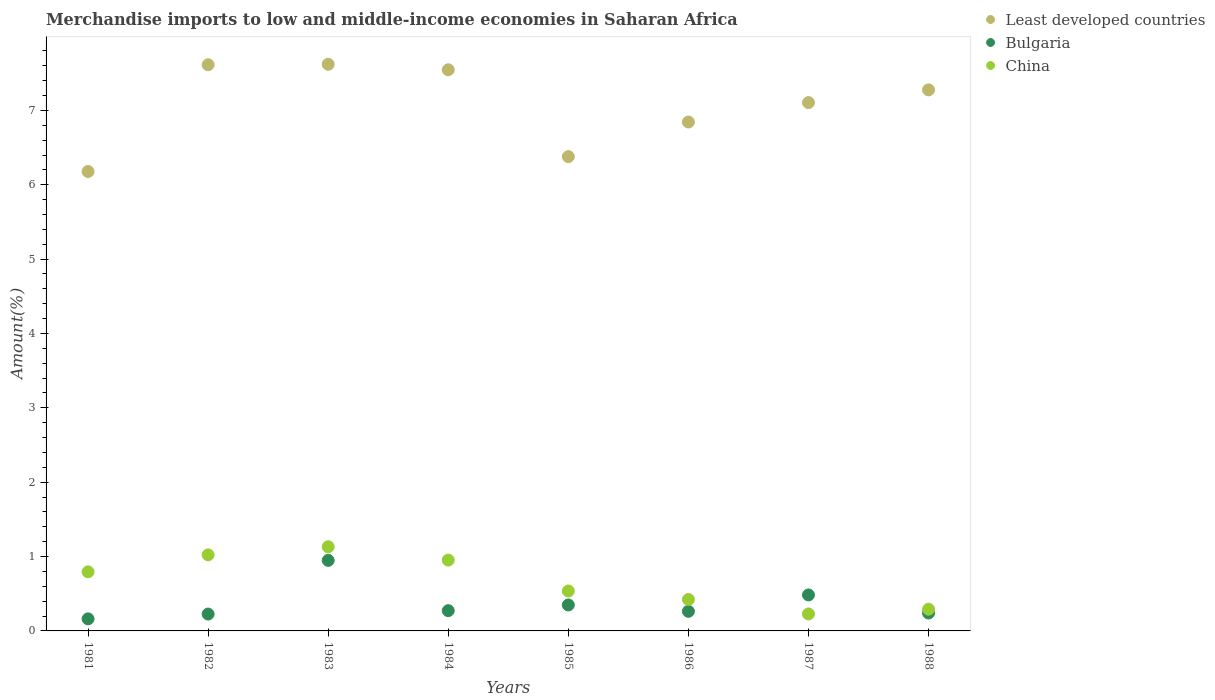What is the percentage of amount earned from merchandise imports in Least developed countries in 1981?
Provide a short and direct response. 6.18. Across all years, what is the maximum percentage of amount earned from merchandise imports in Bulgaria?
Your answer should be compact. 0.95. Across all years, what is the minimum percentage of amount earned from merchandise imports in China?
Your answer should be compact. 0.23. In which year was the percentage of amount earned from merchandise imports in Least developed countries maximum?
Provide a short and direct response. 1983. In which year was the percentage of amount earned from merchandise imports in Bulgaria minimum?
Give a very brief answer. 1981. What is the total percentage of amount earned from merchandise imports in Bulgaria in the graph?
Give a very brief answer. 2.95. What is the difference between the percentage of amount earned from merchandise imports in Least developed countries in 1982 and that in 1984?
Offer a very short reply. 0.07. What is the difference between the percentage of amount earned from merchandise imports in Bulgaria in 1988 and the percentage of amount earned from merchandise imports in China in 1983?
Your answer should be very brief. -0.89. What is the average percentage of amount earned from merchandise imports in Bulgaria per year?
Keep it short and to the point. 0.37. In the year 1985, what is the difference between the percentage of amount earned from merchandise imports in China and percentage of amount earned from merchandise imports in Bulgaria?
Offer a very short reply. 0.19. In how many years, is the percentage of amount earned from merchandise imports in Least developed countries greater than 4 %?
Provide a succinct answer. 8. What is the ratio of the percentage of amount earned from merchandise imports in Bulgaria in 1981 to that in 1988?
Your answer should be very brief. 0.67. Is the percentage of amount earned from merchandise imports in Bulgaria in 1981 less than that in 1987?
Ensure brevity in your answer.  Yes. What is the difference between the highest and the second highest percentage of amount earned from merchandise imports in Least developed countries?
Provide a succinct answer. 0.01. What is the difference between the highest and the lowest percentage of amount earned from merchandise imports in China?
Offer a very short reply. 0.9. Does the percentage of amount earned from merchandise imports in Bulgaria monotonically increase over the years?
Your answer should be compact. No. How many dotlines are there?
Ensure brevity in your answer.  3. How many years are there in the graph?
Offer a very short reply. 8. Are the values on the major ticks of Y-axis written in scientific E-notation?
Your answer should be very brief. No. Does the graph contain any zero values?
Keep it short and to the point. No. How many legend labels are there?
Give a very brief answer. 3. What is the title of the graph?
Your answer should be compact. Merchandise imports to low and middle-income economies in Saharan Africa. What is the label or title of the Y-axis?
Keep it short and to the point. Amount(%). What is the Amount(%) in Least developed countries in 1981?
Give a very brief answer. 6.18. What is the Amount(%) of Bulgaria in 1981?
Provide a succinct answer. 0.16. What is the Amount(%) of China in 1981?
Keep it short and to the point. 0.79. What is the Amount(%) in Least developed countries in 1982?
Provide a short and direct response. 7.61. What is the Amount(%) of Bulgaria in 1982?
Give a very brief answer. 0.23. What is the Amount(%) in China in 1982?
Make the answer very short. 1.02. What is the Amount(%) of Least developed countries in 1983?
Your answer should be compact. 7.62. What is the Amount(%) in Bulgaria in 1983?
Your answer should be very brief. 0.95. What is the Amount(%) in China in 1983?
Make the answer very short. 1.13. What is the Amount(%) of Least developed countries in 1984?
Keep it short and to the point. 7.55. What is the Amount(%) in Bulgaria in 1984?
Your answer should be very brief. 0.27. What is the Amount(%) of China in 1984?
Provide a short and direct response. 0.95. What is the Amount(%) in Least developed countries in 1985?
Your answer should be very brief. 6.38. What is the Amount(%) of Bulgaria in 1985?
Your answer should be compact. 0.35. What is the Amount(%) in China in 1985?
Your answer should be compact. 0.54. What is the Amount(%) in Least developed countries in 1986?
Give a very brief answer. 6.84. What is the Amount(%) of Bulgaria in 1986?
Make the answer very short. 0.26. What is the Amount(%) in China in 1986?
Your answer should be very brief. 0.42. What is the Amount(%) of Least developed countries in 1987?
Keep it short and to the point. 7.11. What is the Amount(%) in Bulgaria in 1987?
Offer a terse response. 0.48. What is the Amount(%) in China in 1987?
Keep it short and to the point. 0.23. What is the Amount(%) in Least developed countries in 1988?
Give a very brief answer. 7.28. What is the Amount(%) in Bulgaria in 1988?
Ensure brevity in your answer.  0.24. What is the Amount(%) of China in 1988?
Provide a succinct answer. 0.29. Across all years, what is the maximum Amount(%) of Least developed countries?
Offer a very short reply. 7.62. Across all years, what is the maximum Amount(%) in Bulgaria?
Your answer should be compact. 0.95. Across all years, what is the maximum Amount(%) in China?
Your answer should be very brief. 1.13. Across all years, what is the minimum Amount(%) of Least developed countries?
Provide a succinct answer. 6.18. Across all years, what is the minimum Amount(%) in Bulgaria?
Your response must be concise. 0.16. Across all years, what is the minimum Amount(%) in China?
Make the answer very short. 0.23. What is the total Amount(%) in Least developed countries in the graph?
Offer a very short reply. 56.56. What is the total Amount(%) of Bulgaria in the graph?
Offer a terse response. 2.95. What is the total Amount(%) of China in the graph?
Your answer should be very brief. 5.38. What is the difference between the Amount(%) in Least developed countries in 1981 and that in 1982?
Keep it short and to the point. -1.44. What is the difference between the Amount(%) of Bulgaria in 1981 and that in 1982?
Offer a terse response. -0.06. What is the difference between the Amount(%) in China in 1981 and that in 1982?
Give a very brief answer. -0.23. What is the difference between the Amount(%) of Least developed countries in 1981 and that in 1983?
Your response must be concise. -1.44. What is the difference between the Amount(%) in Bulgaria in 1981 and that in 1983?
Make the answer very short. -0.79. What is the difference between the Amount(%) of China in 1981 and that in 1983?
Keep it short and to the point. -0.34. What is the difference between the Amount(%) in Least developed countries in 1981 and that in 1984?
Ensure brevity in your answer.  -1.37. What is the difference between the Amount(%) of Bulgaria in 1981 and that in 1984?
Ensure brevity in your answer.  -0.11. What is the difference between the Amount(%) in China in 1981 and that in 1984?
Make the answer very short. -0.16. What is the difference between the Amount(%) in Least developed countries in 1981 and that in 1985?
Provide a short and direct response. -0.2. What is the difference between the Amount(%) of Bulgaria in 1981 and that in 1985?
Provide a short and direct response. -0.19. What is the difference between the Amount(%) of China in 1981 and that in 1985?
Offer a very short reply. 0.26. What is the difference between the Amount(%) of Least developed countries in 1981 and that in 1986?
Provide a short and direct response. -0.67. What is the difference between the Amount(%) of Bulgaria in 1981 and that in 1986?
Ensure brevity in your answer.  -0.1. What is the difference between the Amount(%) in China in 1981 and that in 1986?
Provide a short and direct response. 0.37. What is the difference between the Amount(%) of Least developed countries in 1981 and that in 1987?
Keep it short and to the point. -0.93. What is the difference between the Amount(%) of Bulgaria in 1981 and that in 1987?
Offer a very short reply. -0.32. What is the difference between the Amount(%) of China in 1981 and that in 1987?
Offer a terse response. 0.57. What is the difference between the Amount(%) in Least developed countries in 1981 and that in 1988?
Offer a very short reply. -1.1. What is the difference between the Amount(%) of Bulgaria in 1981 and that in 1988?
Your answer should be very brief. -0.08. What is the difference between the Amount(%) in China in 1981 and that in 1988?
Provide a succinct answer. 0.5. What is the difference between the Amount(%) of Least developed countries in 1982 and that in 1983?
Your answer should be compact. -0.01. What is the difference between the Amount(%) in Bulgaria in 1982 and that in 1983?
Give a very brief answer. -0.72. What is the difference between the Amount(%) of China in 1982 and that in 1983?
Your answer should be very brief. -0.11. What is the difference between the Amount(%) of Least developed countries in 1982 and that in 1984?
Your response must be concise. 0.07. What is the difference between the Amount(%) of Bulgaria in 1982 and that in 1984?
Your answer should be compact. -0.05. What is the difference between the Amount(%) in China in 1982 and that in 1984?
Your answer should be very brief. 0.07. What is the difference between the Amount(%) of Least developed countries in 1982 and that in 1985?
Keep it short and to the point. 1.24. What is the difference between the Amount(%) in Bulgaria in 1982 and that in 1985?
Your answer should be very brief. -0.12. What is the difference between the Amount(%) of China in 1982 and that in 1985?
Ensure brevity in your answer.  0.49. What is the difference between the Amount(%) in Least developed countries in 1982 and that in 1986?
Keep it short and to the point. 0.77. What is the difference between the Amount(%) of Bulgaria in 1982 and that in 1986?
Your answer should be very brief. -0.04. What is the difference between the Amount(%) in China in 1982 and that in 1986?
Your answer should be very brief. 0.6. What is the difference between the Amount(%) of Least developed countries in 1982 and that in 1987?
Offer a terse response. 0.51. What is the difference between the Amount(%) in Bulgaria in 1982 and that in 1987?
Keep it short and to the point. -0.26. What is the difference between the Amount(%) in China in 1982 and that in 1987?
Provide a short and direct response. 0.79. What is the difference between the Amount(%) of Least developed countries in 1982 and that in 1988?
Give a very brief answer. 0.34. What is the difference between the Amount(%) of Bulgaria in 1982 and that in 1988?
Give a very brief answer. -0.01. What is the difference between the Amount(%) of China in 1982 and that in 1988?
Provide a short and direct response. 0.73. What is the difference between the Amount(%) of Least developed countries in 1983 and that in 1984?
Offer a very short reply. 0.07. What is the difference between the Amount(%) in Bulgaria in 1983 and that in 1984?
Your answer should be compact. 0.68. What is the difference between the Amount(%) in China in 1983 and that in 1984?
Your answer should be compact. 0.18. What is the difference between the Amount(%) in Least developed countries in 1983 and that in 1985?
Give a very brief answer. 1.24. What is the difference between the Amount(%) in Bulgaria in 1983 and that in 1985?
Give a very brief answer. 0.6. What is the difference between the Amount(%) of China in 1983 and that in 1985?
Your answer should be very brief. 0.6. What is the difference between the Amount(%) of Least developed countries in 1983 and that in 1986?
Make the answer very short. 0.78. What is the difference between the Amount(%) of Bulgaria in 1983 and that in 1986?
Give a very brief answer. 0.68. What is the difference between the Amount(%) in China in 1983 and that in 1986?
Offer a very short reply. 0.71. What is the difference between the Amount(%) in Least developed countries in 1983 and that in 1987?
Ensure brevity in your answer.  0.51. What is the difference between the Amount(%) of Bulgaria in 1983 and that in 1987?
Your answer should be compact. 0.46. What is the difference between the Amount(%) of China in 1983 and that in 1987?
Offer a terse response. 0.9. What is the difference between the Amount(%) in Least developed countries in 1983 and that in 1988?
Your response must be concise. 0.34. What is the difference between the Amount(%) of Bulgaria in 1983 and that in 1988?
Your answer should be compact. 0.71. What is the difference between the Amount(%) in China in 1983 and that in 1988?
Offer a very short reply. 0.84. What is the difference between the Amount(%) of Least developed countries in 1984 and that in 1985?
Your response must be concise. 1.17. What is the difference between the Amount(%) in Bulgaria in 1984 and that in 1985?
Offer a very short reply. -0.08. What is the difference between the Amount(%) of China in 1984 and that in 1985?
Your answer should be very brief. 0.42. What is the difference between the Amount(%) in Least developed countries in 1984 and that in 1986?
Keep it short and to the point. 0.7. What is the difference between the Amount(%) of Bulgaria in 1984 and that in 1986?
Your answer should be very brief. 0.01. What is the difference between the Amount(%) in China in 1984 and that in 1986?
Provide a short and direct response. 0.53. What is the difference between the Amount(%) in Least developed countries in 1984 and that in 1987?
Offer a very short reply. 0.44. What is the difference between the Amount(%) of Bulgaria in 1984 and that in 1987?
Your response must be concise. -0.21. What is the difference between the Amount(%) in China in 1984 and that in 1987?
Give a very brief answer. 0.72. What is the difference between the Amount(%) in Least developed countries in 1984 and that in 1988?
Your answer should be compact. 0.27. What is the difference between the Amount(%) in Bulgaria in 1984 and that in 1988?
Offer a terse response. 0.03. What is the difference between the Amount(%) in China in 1984 and that in 1988?
Your response must be concise. 0.66. What is the difference between the Amount(%) of Least developed countries in 1985 and that in 1986?
Your answer should be compact. -0.47. What is the difference between the Amount(%) in Bulgaria in 1985 and that in 1986?
Offer a very short reply. 0.09. What is the difference between the Amount(%) in China in 1985 and that in 1986?
Keep it short and to the point. 0.11. What is the difference between the Amount(%) in Least developed countries in 1985 and that in 1987?
Your answer should be very brief. -0.73. What is the difference between the Amount(%) of Bulgaria in 1985 and that in 1987?
Your response must be concise. -0.13. What is the difference between the Amount(%) of China in 1985 and that in 1987?
Ensure brevity in your answer.  0.31. What is the difference between the Amount(%) in Least developed countries in 1985 and that in 1988?
Make the answer very short. -0.9. What is the difference between the Amount(%) in Bulgaria in 1985 and that in 1988?
Ensure brevity in your answer.  0.11. What is the difference between the Amount(%) of China in 1985 and that in 1988?
Keep it short and to the point. 0.24. What is the difference between the Amount(%) in Least developed countries in 1986 and that in 1987?
Give a very brief answer. -0.26. What is the difference between the Amount(%) of Bulgaria in 1986 and that in 1987?
Give a very brief answer. -0.22. What is the difference between the Amount(%) of China in 1986 and that in 1987?
Offer a very short reply. 0.19. What is the difference between the Amount(%) in Least developed countries in 1986 and that in 1988?
Provide a succinct answer. -0.43. What is the difference between the Amount(%) in Bulgaria in 1986 and that in 1988?
Provide a short and direct response. 0.02. What is the difference between the Amount(%) of China in 1986 and that in 1988?
Provide a short and direct response. 0.13. What is the difference between the Amount(%) of Least developed countries in 1987 and that in 1988?
Offer a very short reply. -0.17. What is the difference between the Amount(%) in Bulgaria in 1987 and that in 1988?
Give a very brief answer. 0.24. What is the difference between the Amount(%) in China in 1987 and that in 1988?
Your answer should be very brief. -0.06. What is the difference between the Amount(%) in Least developed countries in 1981 and the Amount(%) in Bulgaria in 1982?
Offer a terse response. 5.95. What is the difference between the Amount(%) of Least developed countries in 1981 and the Amount(%) of China in 1982?
Your answer should be compact. 5.16. What is the difference between the Amount(%) of Bulgaria in 1981 and the Amount(%) of China in 1982?
Give a very brief answer. -0.86. What is the difference between the Amount(%) of Least developed countries in 1981 and the Amount(%) of Bulgaria in 1983?
Keep it short and to the point. 5.23. What is the difference between the Amount(%) in Least developed countries in 1981 and the Amount(%) in China in 1983?
Provide a short and direct response. 5.05. What is the difference between the Amount(%) of Bulgaria in 1981 and the Amount(%) of China in 1983?
Offer a very short reply. -0.97. What is the difference between the Amount(%) in Least developed countries in 1981 and the Amount(%) in Bulgaria in 1984?
Ensure brevity in your answer.  5.91. What is the difference between the Amount(%) of Least developed countries in 1981 and the Amount(%) of China in 1984?
Your answer should be compact. 5.23. What is the difference between the Amount(%) in Bulgaria in 1981 and the Amount(%) in China in 1984?
Ensure brevity in your answer.  -0.79. What is the difference between the Amount(%) of Least developed countries in 1981 and the Amount(%) of Bulgaria in 1985?
Ensure brevity in your answer.  5.83. What is the difference between the Amount(%) of Least developed countries in 1981 and the Amount(%) of China in 1985?
Offer a terse response. 5.64. What is the difference between the Amount(%) in Bulgaria in 1981 and the Amount(%) in China in 1985?
Offer a terse response. -0.37. What is the difference between the Amount(%) of Least developed countries in 1981 and the Amount(%) of Bulgaria in 1986?
Provide a succinct answer. 5.91. What is the difference between the Amount(%) of Least developed countries in 1981 and the Amount(%) of China in 1986?
Offer a terse response. 5.76. What is the difference between the Amount(%) in Bulgaria in 1981 and the Amount(%) in China in 1986?
Provide a succinct answer. -0.26. What is the difference between the Amount(%) of Least developed countries in 1981 and the Amount(%) of Bulgaria in 1987?
Your response must be concise. 5.69. What is the difference between the Amount(%) of Least developed countries in 1981 and the Amount(%) of China in 1987?
Offer a very short reply. 5.95. What is the difference between the Amount(%) in Bulgaria in 1981 and the Amount(%) in China in 1987?
Provide a short and direct response. -0.07. What is the difference between the Amount(%) in Least developed countries in 1981 and the Amount(%) in Bulgaria in 1988?
Make the answer very short. 5.94. What is the difference between the Amount(%) of Least developed countries in 1981 and the Amount(%) of China in 1988?
Your response must be concise. 5.89. What is the difference between the Amount(%) of Bulgaria in 1981 and the Amount(%) of China in 1988?
Provide a succinct answer. -0.13. What is the difference between the Amount(%) of Least developed countries in 1982 and the Amount(%) of Bulgaria in 1983?
Your answer should be very brief. 6.67. What is the difference between the Amount(%) of Least developed countries in 1982 and the Amount(%) of China in 1983?
Offer a very short reply. 6.48. What is the difference between the Amount(%) in Bulgaria in 1982 and the Amount(%) in China in 1983?
Your response must be concise. -0.91. What is the difference between the Amount(%) in Least developed countries in 1982 and the Amount(%) in Bulgaria in 1984?
Give a very brief answer. 7.34. What is the difference between the Amount(%) in Least developed countries in 1982 and the Amount(%) in China in 1984?
Keep it short and to the point. 6.66. What is the difference between the Amount(%) in Bulgaria in 1982 and the Amount(%) in China in 1984?
Offer a very short reply. -0.73. What is the difference between the Amount(%) in Least developed countries in 1982 and the Amount(%) in Bulgaria in 1985?
Ensure brevity in your answer.  7.26. What is the difference between the Amount(%) of Least developed countries in 1982 and the Amount(%) of China in 1985?
Your answer should be compact. 7.08. What is the difference between the Amount(%) in Bulgaria in 1982 and the Amount(%) in China in 1985?
Offer a terse response. -0.31. What is the difference between the Amount(%) of Least developed countries in 1982 and the Amount(%) of Bulgaria in 1986?
Give a very brief answer. 7.35. What is the difference between the Amount(%) of Least developed countries in 1982 and the Amount(%) of China in 1986?
Your response must be concise. 7.19. What is the difference between the Amount(%) in Bulgaria in 1982 and the Amount(%) in China in 1986?
Your response must be concise. -0.2. What is the difference between the Amount(%) of Least developed countries in 1982 and the Amount(%) of Bulgaria in 1987?
Provide a succinct answer. 7.13. What is the difference between the Amount(%) in Least developed countries in 1982 and the Amount(%) in China in 1987?
Make the answer very short. 7.39. What is the difference between the Amount(%) of Bulgaria in 1982 and the Amount(%) of China in 1987?
Offer a very short reply. -0. What is the difference between the Amount(%) in Least developed countries in 1982 and the Amount(%) in Bulgaria in 1988?
Ensure brevity in your answer.  7.37. What is the difference between the Amount(%) in Least developed countries in 1982 and the Amount(%) in China in 1988?
Ensure brevity in your answer.  7.32. What is the difference between the Amount(%) of Bulgaria in 1982 and the Amount(%) of China in 1988?
Keep it short and to the point. -0.07. What is the difference between the Amount(%) in Least developed countries in 1983 and the Amount(%) in Bulgaria in 1984?
Make the answer very short. 7.35. What is the difference between the Amount(%) of Least developed countries in 1983 and the Amount(%) of China in 1984?
Provide a short and direct response. 6.67. What is the difference between the Amount(%) of Bulgaria in 1983 and the Amount(%) of China in 1984?
Your answer should be very brief. -0. What is the difference between the Amount(%) in Least developed countries in 1983 and the Amount(%) in Bulgaria in 1985?
Keep it short and to the point. 7.27. What is the difference between the Amount(%) in Least developed countries in 1983 and the Amount(%) in China in 1985?
Offer a very short reply. 7.08. What is the difference between the Amount(%) of Bulgaria in 1983 and the Amount(%) of China in 1985?
Provide a short and direct response. 0.41. What is the difference between the Amount(%) of Least developed countries in 1983 and the Amount(%) of Bulgaria in 1986?
Your answer should be compact. 7.36. What is the difference between the Amount(%) of Least developed countries in 1983 and the Amount(%) of China in 1986?
Your answer should be compact. 7.2. What is the difference between the Amount(%) in Bulgaria in 1983 and the Amount(%) in China in 1986?
Your response must be concise. 0.53. What is the difference between the Amount(%) in Least developed countries in 1983 and the Amount(%) in Bulgaria in 1987?
Your response must be concise. 7.14. What is the difference between the Amount(%) of Least developed countries in 1983 and the Amount(%) of China in 1987?
Make the answer very short. 7.39. What is the difference between the Amount(%) of Bulgaria in 1983 and the Amount(%) of China in 1987?
Provide a short and direct response. 0.72. What is the difference between the Amount(%) in Least developed countries in 1983 and the Amount(%) in Bulgaria in 1988?
Ensure brevity in your answer.  7.38. What is the difference between the Amount(%) in Least developed countries in 1983 and the Amount(%) in China in 1988?
Your response must be concise. 7.33. What is the difference between the Amount(%) in Bulgaria in 1983 and the Amount(%) in China in 1988?
Give a very brief answer. 0.66. What is the difference between the Amount(%) in Least developed countries in 1984 and the Amount(%) in Bulgaria in 1985?
Give a very brief answer. 7.2. What is the difference between the Amount(%) of Least developed countries in 1984 and the Amount(%) of China in 1985?
Make the answer very short. 7.01. What is the difference between the Amount(%) in Bulgaria in 1984 and the Amount(%) in China in 1985?
Provide a short and direct response. -0.26. What is the difference between the Amount(%) in Least developed countries in 1984 and the Amount(%) in Bulgaria in 1986?
Provide a short and direct response. 7.28. What is the difference between the Amount(%) in Least developed countries in 1984 and the Amount(%) in China in 1986?
Your answer should be compact. 7.12. What is the difference between the Amount(%) in Bulgaria in 1984 and the Amount(%) in China in 1986?
Your answer should be very brief. -0.15. What is the difference between the Amount(%) of Least developed countries in 1984 and the Amount(%) of Bulgaria in 1987?
Ensure brevity in your answer.  7.06. What is the difference between the Amount(%) of Least developed countries in 1984 and the Amount(%) of China in 1987?
Offer a very short reply. 7.32. What is the difference between the Amount(%) in Bulgaria in 1984 and the Amount(%) in China in 1987?
Your answer should be compact. 0.04. What is the difference between the Amount(%) of Least developed countries in 1984 and the Amount(%) of Bulgaria in 1988?
Ensure brevity in your answer.  7.31. What is the difference between the Amount(%) in Least developed countries in 1984 and the Amount(%) in China in 1988?
Your answer should be compact. 7.25. What is the difference between the Amount(%) in Bulgaria in 1984 and the Amount(%) in China in 1988?
Ensure brevity in your answer.  -0.02. What is the difference between the Amount(%) in Least developed countries in 1985 and the Amount(%) in Bulgaria in 1986?
Give a very brief answer. 6.12. What is the difference between the Amount(%) of Least developed countries in 1985 and the Amount(%) of China in 1986?
Provide a succinct answer. 5.96. What is the difference between the Amount(%) in Bulgaria in 1985 and the Amount(%) in China in 1986?
Offer a very short reply. -0.07. What is the difference between the Amount(%) in Least developed countries in 1985 and the Amount(%) in Bulgaria in 1987?
Your answer should be very brief. 5.89. What is the difference between the Amount(%) in Least developed countries in 1985 and the Amount(%) in China in 1987?
Your answer should be compact. 6.15. What is the difference between the Amount(%) of Bulgaria in 1985 and the Amount(%) of China in 1987?
Your answer should be compact. 0.12. What is the difference between the Amount(%) of Least developed countries in 1985 and the Amount(%) of Bulgaria in 1988?
Provide a succinct answer. 6.14. What is the difference between the Amount(%) of Least developed countries in 1985 and the Amount(%) of China in 1988?
Provide a short and direct response. 6.09. What is the difference between the Amount(%) of Bulgaria in 1985 and the Amount(%) of China in 1988?
Give a very brief answer. 0.06. What is the difference between the Amount(%) of Least developed countries in 1986 and the Amount(%) of Bulgaria in 1987?
Make the answer very short. 6.36. What is the difference between the Amount(%) of Least developed countries in 1986 and the Amount(%) of China in 1987?
Ensure brevity in your answer.  6.62. What is the difference between the Amount(%) in Bulgaria in 1986 and the Amount(%) in China in 1987?
Make the answer very short. 0.04. What is the difference between the Amount(%) of Least developed countries in 1986 and the Amount(%) of Bulgaria in 1988?
Provide a short and direct response. 6.6. What is the difference between the Amount(%) in Least developed countries in 1986 and the Amount(%) in China in 1988?
Keep it short and to the point. 6.55. What is the difference between the Amount(%) in Bulgaria in 1986 and the Amount(%) in China in 1988?
Make the answer very short. -0.03. What is the difference between the Amount(%) in Least developed countries in 1987 and the Amount(%) in Bulgaria in 1988?
Offer a terse response. 6.86. What is the difference between the Amount(%) of Least developed countries in 1987 and the Amount(%) of China in 1988?
Your answer should be very brief. 6.81. What is the difference between the Amount(%) in Bulgaria in 1987 and the Amount(%) in China in 1988?
Give a very brief answer. 0.19. What is the average Amount(%) of Least developed countries per year?
Make the answer very short. 7.07. What is the average Amount(%) in Bulgaria per year?
Provide a succinct answer. 0.37. What is the average Amount(%) of China per year?
Offer a very short reply. 0.67. In the year 1981, what is the difference between the Amount(%) of Least developed countries and Amount(%) of Bulgaria?
Offer a very short reply. 6.02. In the year 1981, what is the difference between the Amount(%) in Least developed countries and Amount(%) in China?
Offer a terse response. 5.38. In the year 1981, what is the difference between the Amount(%) in Bulgaria and Amount(%) in China?
Your answer should be compact. -0.63. In the year 1982, what is the difference between the Amount(%) in Least developed countries and Amount(%) in Bulgaria?
Make the answer very short. 7.39. In the year 1982, what is the difference between the Amount(%) of Least developed countries and Amount(%) of China?
Offer a very short reply. 6.59. In the year 1982, what is the difference between the Amount(%) of Bulgaria and Amount(%) of China?
Provide a short and direct response. -0.8. In the year 1983, what is the difference between the Amount(%) in Least developed countries and Amount(%) in Bulgaria?
Give a very brief answer. 6.67. In the year 1983, what is the difference between the Amount(%) in Least developed countries and Amount(%) in China?
Provide a short and direct response. 6.49. In the year 1983, what is the difference between the Amount(%) of Bulgaria and Amount(%) of China?
Your answer should be very brief. -0.18. In the year 1984, what is the difference between the Amount(%) of Least developed countries and Amount(%) of Bulgaria?
Offer a very short reply. 7.27. In the year 1984, what is the difference between the Amount(%) of Least developed countries and Amount(%) of China?
Provide a succinct answer. 6.59. In the year 1984, what is the difference between the Amount(%) in Bulgaria and Amount(%) in China?
Provide a short and direct response. -0.68. In the year 1985, what is the difference between the Amount(%) in Least developed countries and Amount(%) in Bulgaria?
Provide a short and direct response. 6.03. In the year 1985, what is the difference between the Amount(%) of Least developed countries and Amount(%) of China?
Your answer should be compact. 5.84. In the year 1985, what is the difference between the Amount(%) of Bulgaria and Amount(%) of China?
Make the answer very short. -0.19. In the year 1986, what is the difference between the Amount(%) in Least developed countries and Amount(%) in Bulgaria?
Provide a succinct answer. 6.58. In the year 1986, what is the difference between the Amount(%) in Least developed countries and Amount(%) in China?
Your response must be concise. 6.42. In the year 1986, what is the difference between the Amount(%) of Bulgaria and Amount(%) of China?
Keep it short and to the point. -0.16. In the year 1987, what is the difference between the Amount(%) of Least developed countries and Amount(%) of Bulgaria?
Offer a terse response. 6.62. In the year 1987, what is the difference between the Amount(%) in Least developed countries and Amount(%) in China?
Your answer should be very brief. 6.88. In the year 1987, what is the difference between the Amount(%) in Bulgaria and Amount(%) in China?
Offer a very short reply. 0.26. In the year 1988, what is the difference between the Amount(%) in Least developed countries and Amount(%) in Bulgaria?
Give a very brief answer. 7.04. In the year 1988, what is the difference between the Amount(%) of Least developed countries and Amount(%) of China?
Provide a short and direct response. 6.98. In the year 1988, what is the difference between the Amount(%) of Bulgaria and Amount(%) of China?
Offer a terse response. -0.05. What is the ratio of the Amount(%) of Least developed countries in 1981 to that in 1982?
Offer a terse response. 0.81. What is the ratio of the Amount(%) in Bulgaria in 1981 to that in 1982?
Your answer should be compact. 0.72. What is the ratio of the Amount(%) in China in 1981 to that in 1982?
Keep it short and to the point. 0.78. What is the ratio of the Amount(%) of Least developed countries in 1981 to that in 1983?
Give a very brief answer. 0.81. What is the ratio of the Amount(%) of Bulgaria in 1981 to that in 1983?
Offer a terse response. 0.17. What is the ratio of the Amount(%) in China in 1981 to that in 1983?
Offer a terse response. 0.7. What is the ratio of the Amount(%) in Least developed countries in 1981 to that in 1984?
Offer a terse response. 0.82. What is the ratio of the Amount(%) in Bulgaria in 1981 to that in 1984?
Keep it short and to the point. 0.6. What is the ratio of the Amount(%) in China in 1981 to that in 1984?
Give a very brief answer. 0.83. What is the ratio of the Amount(%) of Least developed countries in 1981 to that in 1985?
Keep it short and to the point. 0.97. What is the ratio of the Amount(%) in Bulgaria in 1981 to that in 1985?
Make the answer very short. 0.46. What is the ratio of the Amount(%) in China in 1981 to that in 1985?
Your answer should be compact. 1.48. What is the ratio of the Amount(%) of Least developed countries in 1981 to that in 1986?
Offer a terse response. 0.9. What is the ratio of the Amount(%) of Bulgaria in 1981 to that in 1986?
Ensure brevity in your answer.  0.62. What is the ratio of the Amount(%) in China in 1981 to that in 1986?
Your response must be concise. 1.88. What is the ratio of the Amount(%) of Least developed countries in 1981 to that in 1987?
Make the answer very short. 0.87. What is the ratio of the Amount(%) in Bulgaria in 1981 to that in 1987?
Provide a short and direct response. 0.34. What is the ratio of the Amount(%) in China in 1981 to that in 1987?
Ensure brevity in your answer.  3.48. What is the ratio of the Amount(%) in Least developed countries in 1981 to that in 1988?
Give a very brief answer. 0.85. What is the ratio of the Amount(%) of Bulgaria in 1981 to that in 1988?
Offer a terse response. 0.67. What is the ratio of the Amount(%) of China in 1981 to that in 1988?
Your answer should be very brief. 2.72. What is the ratio of the Amount(%) of Least developed countries in 1982 to that in 1983?
Ensure brevity in your answer.  1. What is the ratio of the Amount(%) of Bulgaria in 1982 to that in 1983?
Provide a succinct answer. 0.24. What is the ratio of the Amount(%) of China in 1982 to that in 1983?
Offer a very short reply. 0.9. What is the ratio of the Amount(%) in Least developed countries in 1982 to that in 1984?
Your response must be concise. 1.01. What is the ratio of the Amount(%) in Bulgaria in 1982 to that in 1984?
Ensure brevity in your answer.  0.83. What is the ratio of the Amount(%) of China in 1982 to that in 1984?
Offer a very short reply. 1.07. What is the ratio of the Amount(%) in Least developed countries in 1982 to that in 1985?
Make the answer very short. 1.19. What is the ratio of the Amount(%) of Bulgaria in 1982 to that in 1985?
Offer a very short reply. 0.65. What is the ratio of the Amount(%) of China in 1982 to that in 1985?
Provide a short and direct response. 1.91. What is the ratio of the Amount(%) of Least developed countries in 1982 to that in 1986?
Ensure brevity in your answer.  1.11. What is the ratio of the Amount(%) of Bulgaria in 1982 to that in 1986?
Make the answer very short. 0.86. What is the ratio of the Amount(%) of China in 1982 to that in 1986?
Keep it short and to the point. 2.42. What is the ratio of the Amount(%) in Least developed countries in 1982 to that in 1987?
Offer a very short reply. 1.07. What is the ratio of the Amount(%) in Bulgaria in 1982 to that in 1987?
Keep it short and to the point. 0.47. What is the ratio of the Amount(%) of China in 1982 to that in 1987?
Give a very brief answer. 4.48. What is the ratio of the Amount(%) in Least developed countries in 1982 to that in 1988?
Provide a short and direct response. 1.05. What is the ratio of the Amount(%) in Bulgaria in 1982 to that in 1988?
Your answer should be very brief. 0.94. What is the ratio of the Amount(%) in China in 1982 to that in 1988?
Provide a succinct answer. 3.5. What is the ratio of the Amount(%) in Least developed countries in 1983 to that in 1984?
Your answer should be compact. 1.01. What is the ratio of the Amount(%) of Bulgaria in 1983 to that in 1984?
Make the answer very short. 3.48. What is the ratio of the Amount(%) in China in 1983 to that in 1984?
Your answer should be very brief. 1.19. What is the ratio of the Amount(%) in Least developed countries in 1983 to that in 1985?
Your answer should be very brief. 1.19. What is the ratio of the Amount(%) in Bulgaria in 1983 to that in 1985?
Offer a very short reply. 2.72. What is the ratio of the Amount(%) in China in 1983 to that in 1985?
Keep it short and to the point. 2.11. What is the ratio of the Amount(%) in Least developed countries in 1983 to that in 1986?
Offer a terse response. 1.11. What is the ratio of the Amount(%) of Bulgaria in 1983 to that in 1986?
Your response must be concise. 3.6. What is the ratio of the Amount(%) of China in 1983 to that in 1986?
Provide a short and direct response. 2.68. What is the ratio of the Amount(%) in Least developed countries in 1983 to that in 1987?
Keep it short and to the point. 1.07. What is the ratio of the Amount(%) in Bulgaria in 1983 to that in 1987?
Your answer should be very brief. 1.96. What is the ratio of the Amount(%) in China in 1983 to that in 1987?
Ensure brevity in your answer.  4.96. What is the ratio of the Amount(%) in Least developed countries in 1983 to that in 1988?
Offer a very short reply. 1.05. What is the ratio of the Amount(%) of Bulgaria in 1983 to that in 1988?
Offer a terse response. 3.94. What is the ratio of the Amount(%) in China in 1983 to that in 1988?
Offer a terse response. 3.88. What is the ratio of the Amount(%) of Least developed countries in 1984 to that in 1985?
Your answer should be very brief. 1.18. What is the ratio of the Amount(%) of Bulgaria in 1984 to that in 1985?
Offer a terse response. 0.78. What is the ratio of the Amount(%) of China in 1984 to that in 1985?
Keep it short and to the point. 1.77. What is the ratio of the Amount(%) of Least developed countries in 1984 to that in 1986?
Your response must be concise. 1.1. What is the ratio of the Amount(%) of Bulgaria in 1984 to that in 1986?
Provide a short and direct response. 1.03. What is the ratio of the Amount(%) in China in 1984 to that in 1986?
Make the answer very short. 2.25. What is the ratio of the Amount(%) in Least developed countries in 1984 to that in 1987?
Keep it short and to the point. 1.06. What is the ratio of the Amount(%) in Bulgaria in 1984 to that in 1987?
Keep it short and to the point. 0.56. What is the ratio of the Amount(%) in China in 1984 to that in 1987?
Keep it short and to the point. 4.18. What is the ratio of the Amount(%) in Least developed countries in 1984 to that in 1988?
Provide a short and direct response. 1.04. What is the ratio of the Amount(%) of Bulgaria in 1984 to that in 1988?
Your answer should be very brief. 1.13. What is the ratio of the Amount(%) of China in 1984 to that in 1988?
Make the answer very short. 3.26. What is the ratio of the Amount(%) of Least developed countries in 1985 to that in 1986?
Provide a short and direct response. 0.93. What is the ratio of the Amount(%) of Bulgaria in 1985 to that in 1986?
Keep it short and to the point. 1.33. What is the ratio of the Amount(%) of China in 1985 to that in 1986?
Offer a very short reply. 1.27. What is the ratio of the Amount(%) in Least developed countries in 1985 to that in 1987?
Your response must be concise. 0.9. What is the ratio of the Amount(%) of Bulgaria in 1985 to that in 1987?
Make the answer very short. 0.72. What is the ratio of the Amount(%) in China in 1985 to that in 1987?
Your response must be concise. 2.35. What is the ratio of the Amount(%) in Least developed countries in 1985 to that in 1988?
Provide a succinct answer. 0.88. What is the ratio of the Amount(%) in Bulgaria in 1985 to that in 1988?
Your answer should be compact. 1.45. What is the ratio of the Amount(%) in China in 1985 to that in 1988?
Offer a terse response. 1.84. What is the ratio of the Amount(%) of Least developed countries in 1986 to that in 1987?
Offer a terse response. 0.96. What is the ratio of the Amount(%) of Bulgaria in 1986 to that in 1987?
Provide a short and direct response. 0.54. What is the ratio of the Amount(%) of China in 1986 to that in 1987?
Provide a short and direct response. 1.85. What is the ratio of the Amount(%) in Least developed countries in 1986 to that in 1988?
Make the answer very short. 0.94. What is the ratio of the Amount(%) of Bulgaria in 1986 to that in 1988?
Your answer should be compact. 1.09. What is the ratio of the Amount(%) of China in 1986 to that in 1988?
Give a very brief answer. 1.45. What is the ratio of the Amount(%) of Least developed countries in 1987 to that in 1988?
Provide a succinct answer. 0.98. What is the ratio of the Amount(%) of Bulgaria in 1987 to that in 1988?
Provide a succinct answer. 2.01. What is the ratio of the Amount(%) of China in 1987 to that in 1988?
Make the answer very short. 0.78. What is the difference between the highest and the second highest Amount(%) in Least developed countries?
Provide a short and direct response. 0.01. What is the difference between the highest and the second highest Amount(%) of Bulgaria?
Offer a very short reply. 0.46. What is the difference between the highest and the second highest Amount(%) of China?
Offer a very short reply. 0.11. What is the difference between the highest and the lowest Amount(%) of Least developed countries?
Offer a terse response. 1.44. What is the difference between the highest and the lowest Amount(%) of Bulgaria?
Provide a short and direct response. 0.79. What is the difference between the highest and the lowest Amount(%) in China?
Ensure brevity in your answer.  0.9. 